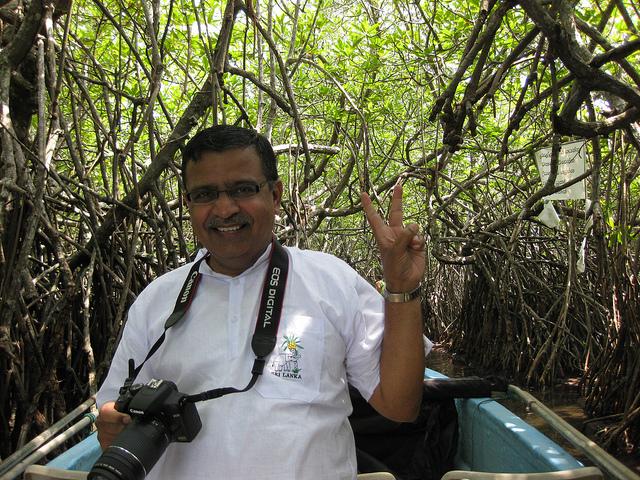Is he on vacation?
Give a very brief answer. Yes. Is he in an angry mood?
Quick response, please. No. What is the man holding?
Concise answer only. Camera. 